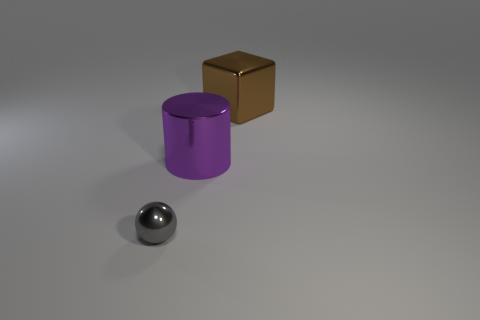Add 3 brown things. How many objects exist? 6 Subtract all blocks. How many objects are left? 2 Add 3 big blocks. How many big blocks exist? 4 Subtract 1 brown cubes. How many objects are left? 2 Subtract all red cubes. Subtract all metallic things. How many objects are left? 0 Add 1 large brown objects. How many large brown objects are left? 2 